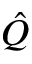Convert formula to latex. <formula><loc_0><loc_0><loc_500><loc_500>\hat { Q }</formula> 